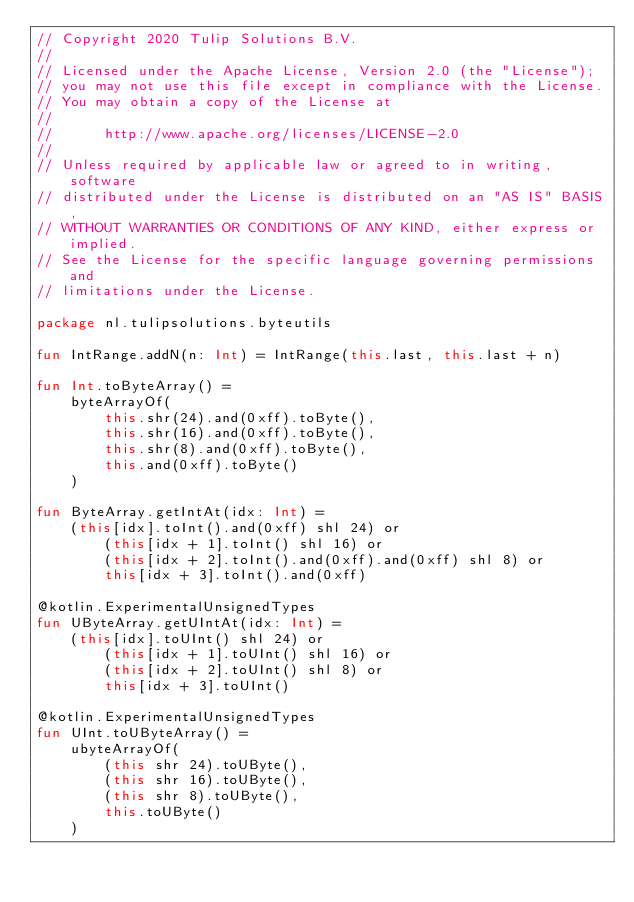<code> <loc_0><loc_0><loc_500><loc_500><_Kotlin_>// Copyright 2020 Tulip Solutions B.V.
//
// Licensed under the Apache License, Version 2.0 (the "License");
// you may not use this file except in compliance with the License.
// You may obtain a copy of the License at
//
//      http://www.apache.org/licenses/LICENSE-2.0
//
// Unless required by applicable law or agreed to in writing, software
// distributed under the License is distributed on an "AS IS" BASIS,
// WITHOUT WARRANTIES OR CONDITIONS OF ANY KIND, either express or implied.
// See the License for the specific language governing permissions and
// limitations under the License.

package nl.tulipsolutions.byteutils

fun IntRange.addN(n: Int) = IntRange(this.last, this.last + n)

fun Int.toByteArray() =
    byteArrayOf(
        this.shr(24).and(0xff).toByte(),
        this.shr(16).and(0xff).toByte(),
        this.shr(8).and(0xff).toByte(),
        this.and(0xff).toByte()
    )

fun ByteArray.getIntAt(idx: Int) =
    (this[idx].toInt().and(0xff) shl 24) or
        (this[idx + 1].toInt() shl 16) or
        (this[idx + 2].toInt().and(0xff).and(0xff) shl 8) or
        this[idx + 3].toInt().and(0xff)

@kotlin.ExperimentalUnsignedTypes
fun UByteArray.getUIntAt(idx: Int) =
    (this[idx].toUInt() shl 24) or
        (this[idx + 1].toUInt() shl 16) or
        (this[idx + 2].toUInt() shl 8) or
        this[idx + 3].toUInt()

@kotlin.ExperimentalUnsignedTypes
fun UInt.toUByteArray() =
    ubyteArrayOf(
        (this shr 24).toUByte(),
        (this shr 16).toUByte(),
        (this shr 8).toUByte(),
        this.toUByte()
    )
</code> 